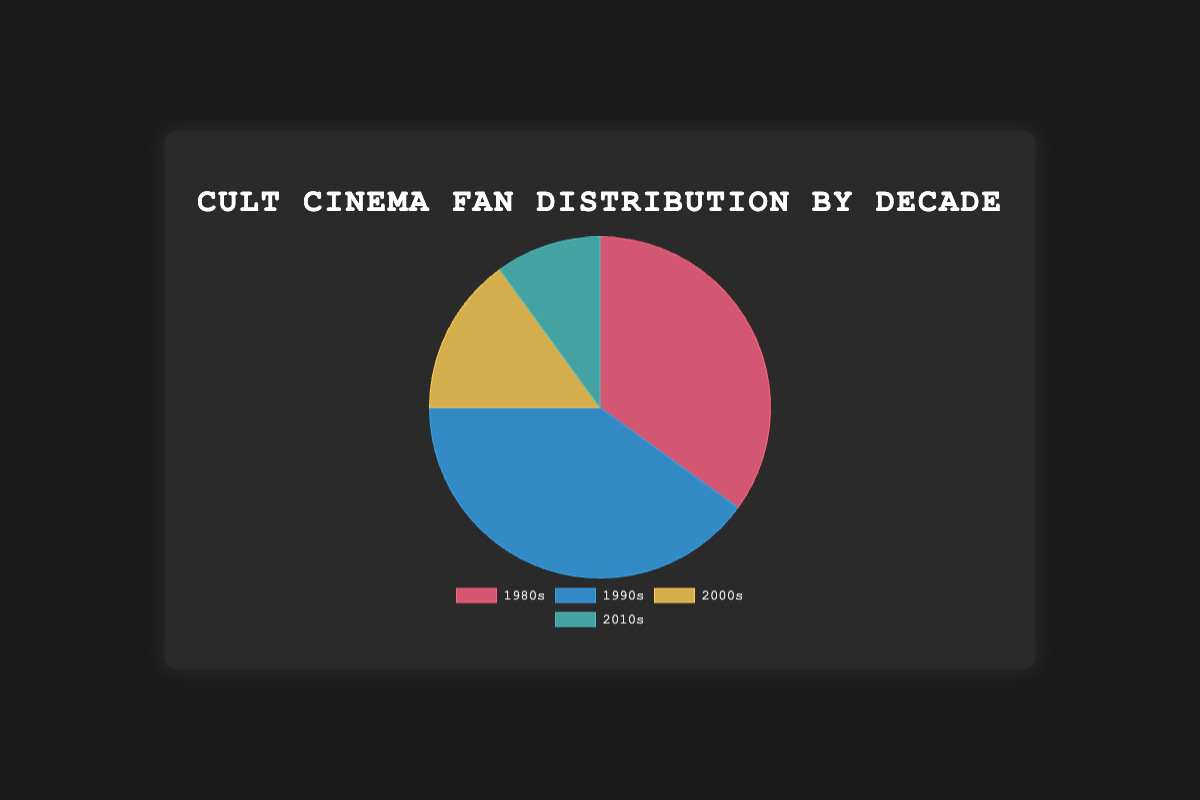Which decade has the highest percentage of cult cinema fans? Look at the pie chart and identify the largest segment. The largest segment corresponds to the 1990s with 40%.
Answer: 1990s Which decade has the lowest percentage of cult cinema fans? Look at the pie chart and identify the smallest segment. The smallest segment corresponds to the 2010s with 10%.
Answer: 2010s How do the combined percentages of fans for 1980s and 1990s compare to those for 2000s and 2010s? Sum the percentages for 1980s and 1990s (35% + 40% = 75%) and compare with the sum for 2000s and 2010s (15% + 10% = 25%).
Answer: The combined percentage for 1980s and 1990s is greater What is the difference in percentage points between fans of the 1990s and fans of the 2000s? Subtract the percentage of fans of the 2000s (15%) from the percentage of fans of the 1990s (40%). 40% - 15% = 25%.
Answer: 25 percentage points What percentage of cult cinema fans prefer movies from the 21st century (2000s and 2010s combined)? Sum the percentages for the 2000s and the 2010s (15% + 10% = 25%).
Answer: 25% Is the percentage of fans for the 1990s greater than the combined percentage of those for the 2000s and 2010s? Compare the percentage for the 1990s (40%) with the combined percentages of the 2000s and 2010s (15% + 10% = 25%).
Answer: Yes What is the total percentage of fans who prefer movies from the 1980s and 2000s combined? Sum the percentages for the 1980s and the 2000s (35% + 15% = 50%).
Answer: 50% Which color represents the 1980s decade in the chart? Identify the segment color associated with the 1980s label in the pie chart.
Answer: Red How many more percentage points of fans prefer the 1980s over the 2010s? Subtract the percentage of fans of the 2010s (10%) from the percentage of fans of the 1980s (35%). 35% - 10% = 25%.
Answer: 25 percentage points What is the combined percentage of fans preferring pre-2000s movies (1980s and 1990s)? Sum the percentages for the 1980s and the 1990s (35% + 40% = 75%).
Answer: 75% 